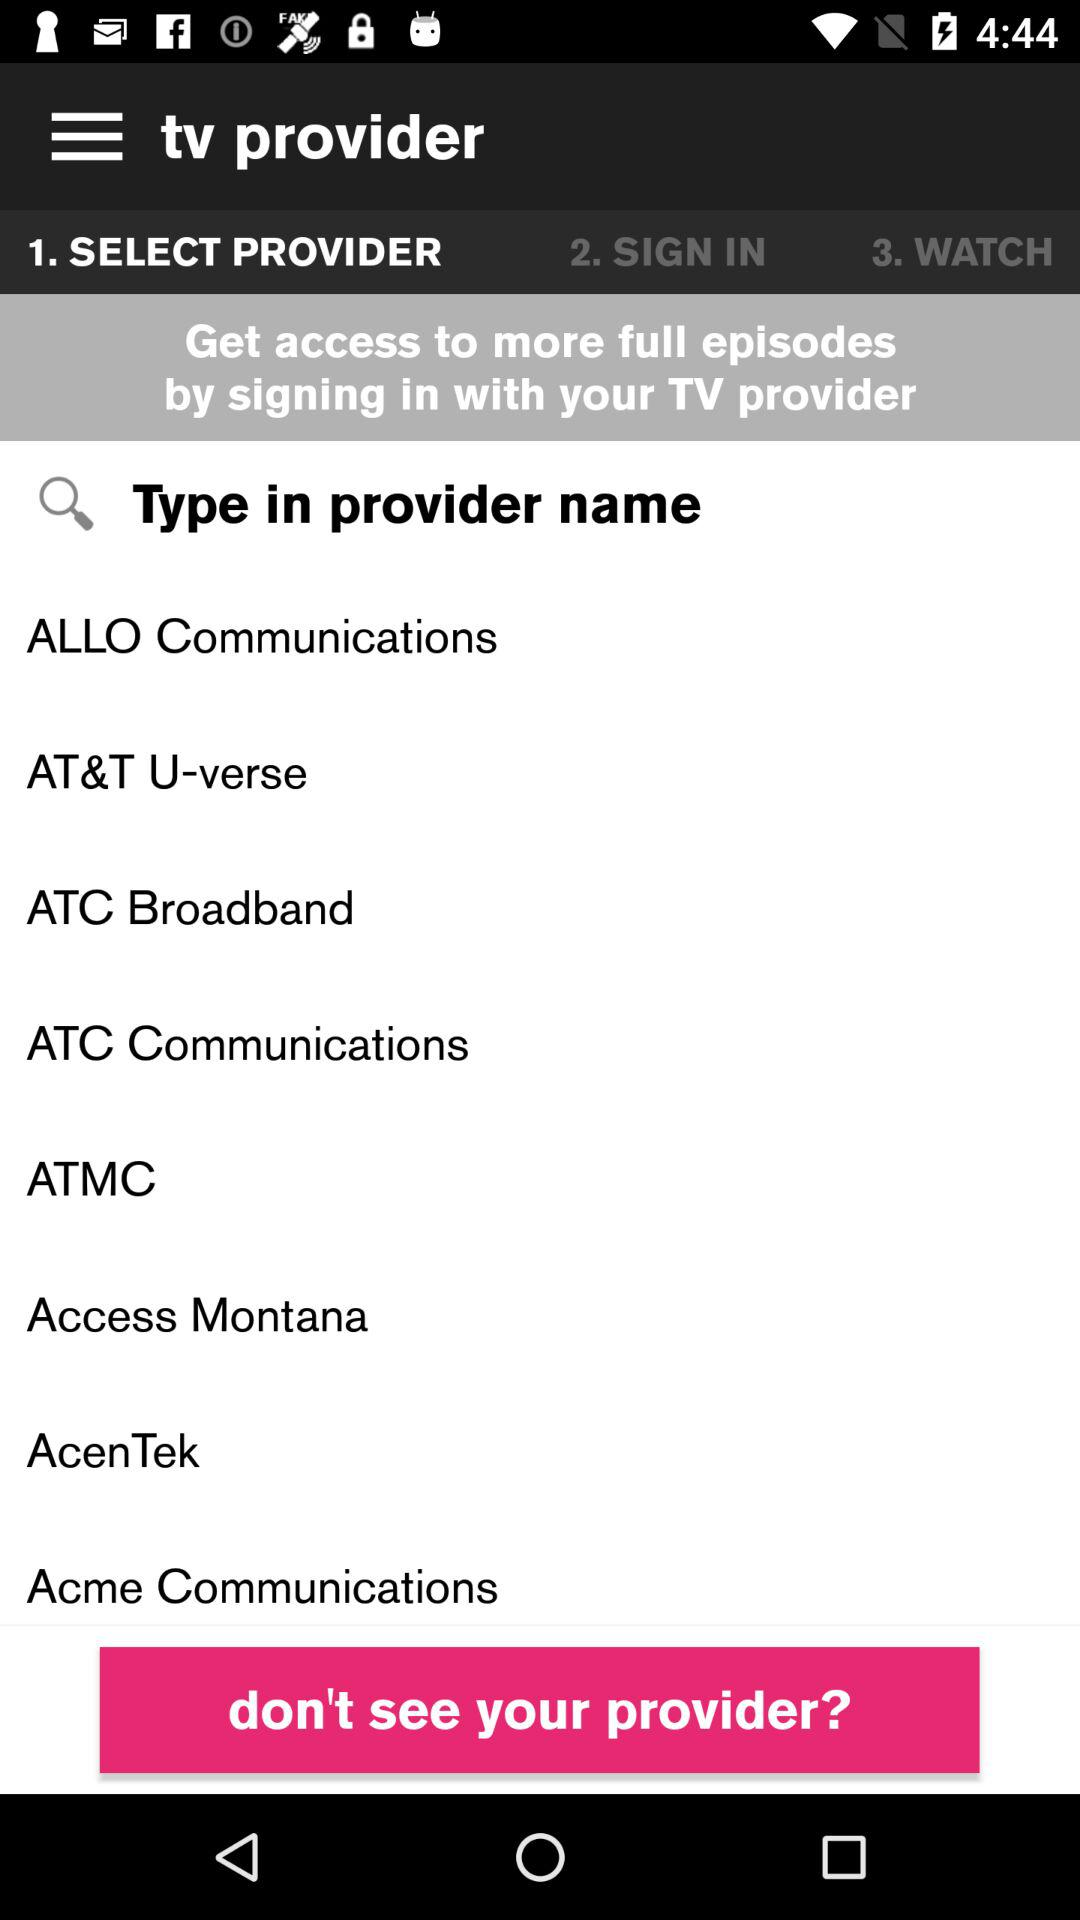How many provider names are on the screen?
Answer the question using a single word or phrase. 8 